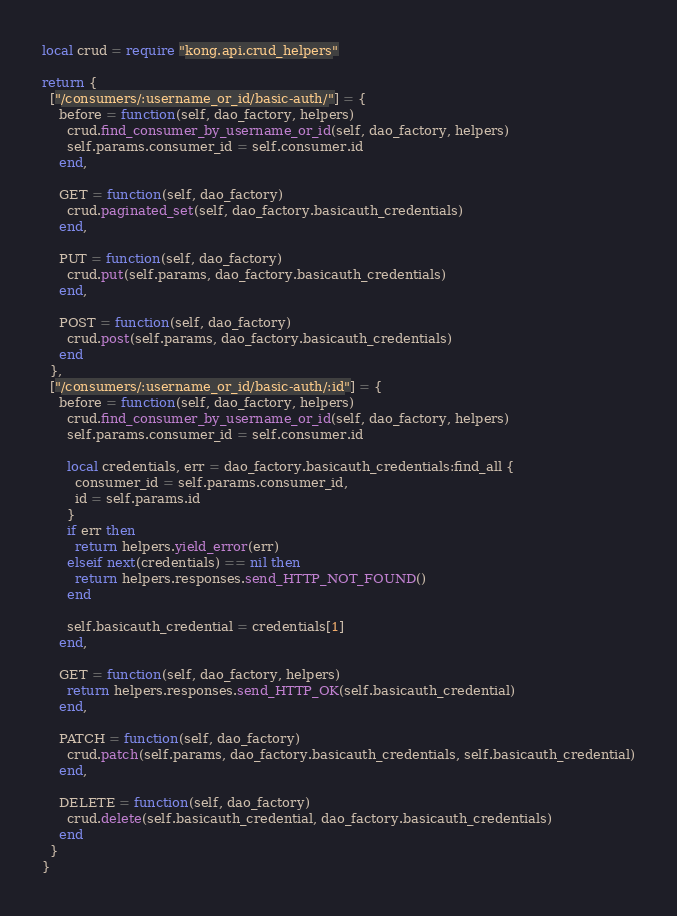Convert code to text. <code><loc_0><loc_0><loc_500><loc_500><_Lua_>local crud = require "kong.api.crud_helpers"

return {
  ["/consumers/:username_or_id/basic-auth/"] = {
    before = function(self, dao_factory, helpers)
      crud.find_consumer_by_username_or_id(self, dao_factory, helpers)
      self.params.consumer_id = self.consumer.id
    end,

    GET = function(self, dao_factory)
      crud.paginated_set(self, dao_factory.basicauth_credentials)
    end,

    PUT = function(self, dao_factory)
      crud.put(self.params, dao_factory.basicauth_credentials)
    end,

    POST = function(self, dao_factory)
      crud.post(self.params, dao_factory.basicauth_credentials)
    end
  },
  ["/consumers/:username_or_id/basic-auth/:id"] = {
    before = function(self, dao_factory, helpers)
      crud.find_consumer_by_username_or_id(self, dao_factory, helpers)
      self.params.consumer_id = self.consumer.id

      local credentials, err = dao_factory.basicauth_credentials:find_all {
        consumer_id = self.params.consumer_id,
        id = self.params.id
      }
      if err then
        return helpers.yield_error(err)
      elseif next(credentials) == nil then
        return helpers.responses.send_HTTP_NOT_FOUND()
      end

      self.basicauth_credential = credentials[1]
    end,

    GET = function(self, dao_factory, helpers)
      return helpers.responses.send_HTTP_OK(self.basicauth_credential)
    end,

    PATCH = function(self, dao_factory)
      crud.patch(self.params, dao_factory.basicauth_credentials, self.basicauth_credential)
    end,

    DELETE = function(self, dao_factory)
      crud.delete(self.basicauth_credential, dao_factory.basicauth_credentials)
    end
  }
}
</code> 